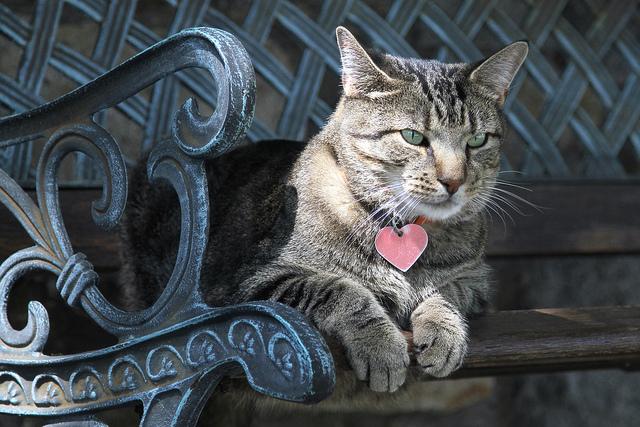What does the cat have on the collar?
Write a very short answer. Heart. Is the cat sleeping?
Quick response, please. No. What is between the camera and the cat?
Write a very short answer. Bench. Does this cat have stripes?
Quick response, please. Yes. 